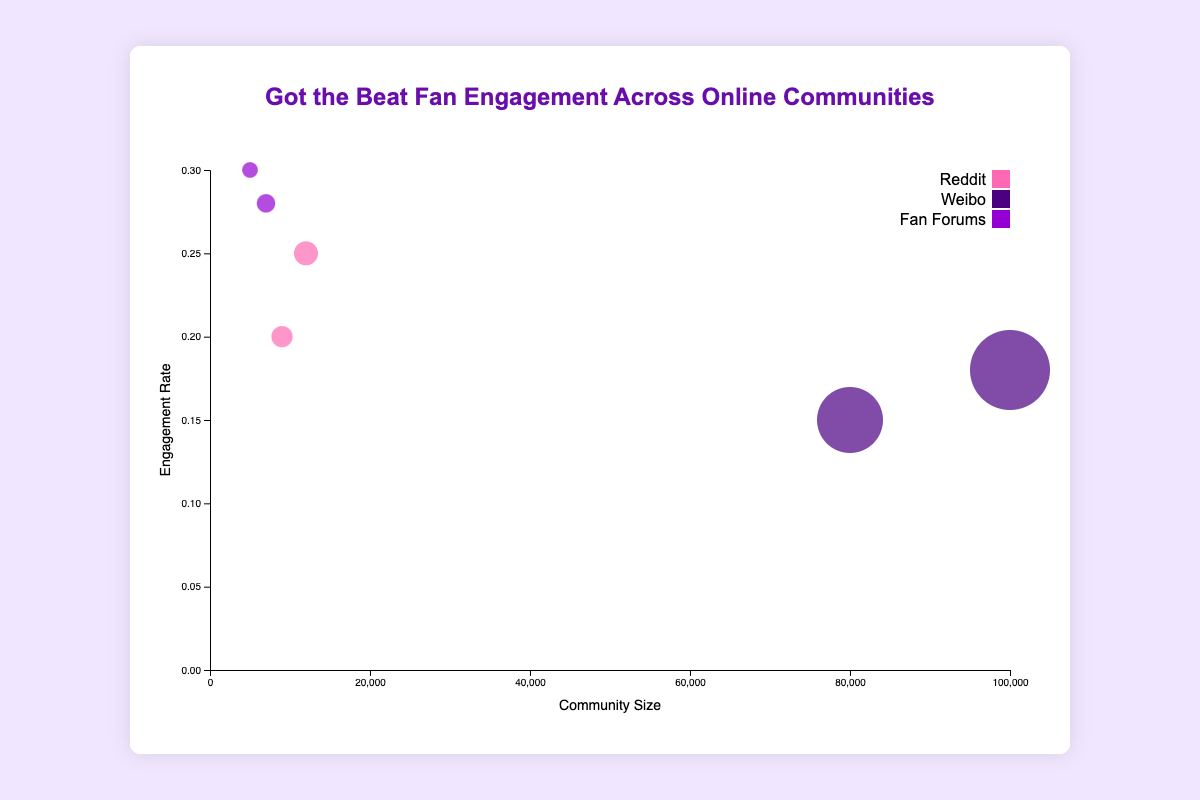1. What is the engagement rate of the Got_the_Beat_Fans community? The Got_the_Beat_Fans community has an engagement rate of 0.3, as indicated by its position on the y-axis of the bubble chart.
Answer: 0.3 2. Which community has the largest community size? Weibo is the community with the largest community size, as it reaches the maximum value on the x-axis at 100,000.
Answer: Weibo 3. How many data points are present in the bubble chart representing fan engagement? There are six data points, each represented by a bubble with different sizes and positions on the chart.
Answer: 6 4. Which has a higher engagement rate: Reddit with a community size of 12,000 or Reddit with a community size of 9,000? By comparing their positions on the y-axis, Reddit with a community size of 12,000 has a higher engagement rate (0.25) than Reddit with a community size of 9,000 (0.2).
Answer: Reddit with 12,000 5. Explain why there are two different colors for Fan Forums in the chart. The two Fan Forums ('Got_the_Beat_Fans' and 'Worldwide_Got_the_Beat') are visually differentiated by using unique colors for better distinction. Both are grouped under "Fan Forums" but have different community names, thus requiring distinct identification.
Answer: Different names 6. Which community has the highest average daily posts, and what are the engagement rate and community size for this community? The Weibo community with 100,000 members has the highest average daily posts (250). The corresponding engagement rate is 0.18, and the community size is 100,000, as discerned from the tooltip information when hovered over this bubble.
Answer: Weibo (250 daily posts, 0.18 engagement rate, 100,000 size) 7. What is the average engagement rate of all data points combined? Adding the engagement rates of all communities (0.25 + 0.15 + 0.3 + 0.28 + 0.2 + 0.18) gives 1.36. Dividing this sum by the 6 data points results in an average engagement rate of 1.36 / 6 = 0.2267.
Answer: 0.2267 8. Compare the average daily posts between the two Weibo communities. Which one has more? The two Weibo communities have 200 and 250 average daily posts, respectively. Comparing these values, the Weibo community with 100,000 members has more average daily posts (250) than the one with 80,000 members (200).
Answer: Weibo with 100,000 members 9. Which community appears the smallest in terms of community size and engagement rate? The bubble representing 'Fan Forums' with the community name 'Got_the_Beat_Fans' is the smallest in terms of both community size (5,000) and engagement rate (0.3). Addition by the smaller x and y-coordinate positions relative to others.
Answer: Got_the_Beat_Fans 10. If the sum of engagement rates for Reddit communities is 0.25 and 0.2, what is the combined sum of engagement rates for Weibo communities? Adding the engagement rates of Weibo communities, we get 0.15 + 0.18 = 0.33.
Answer: 0.33 